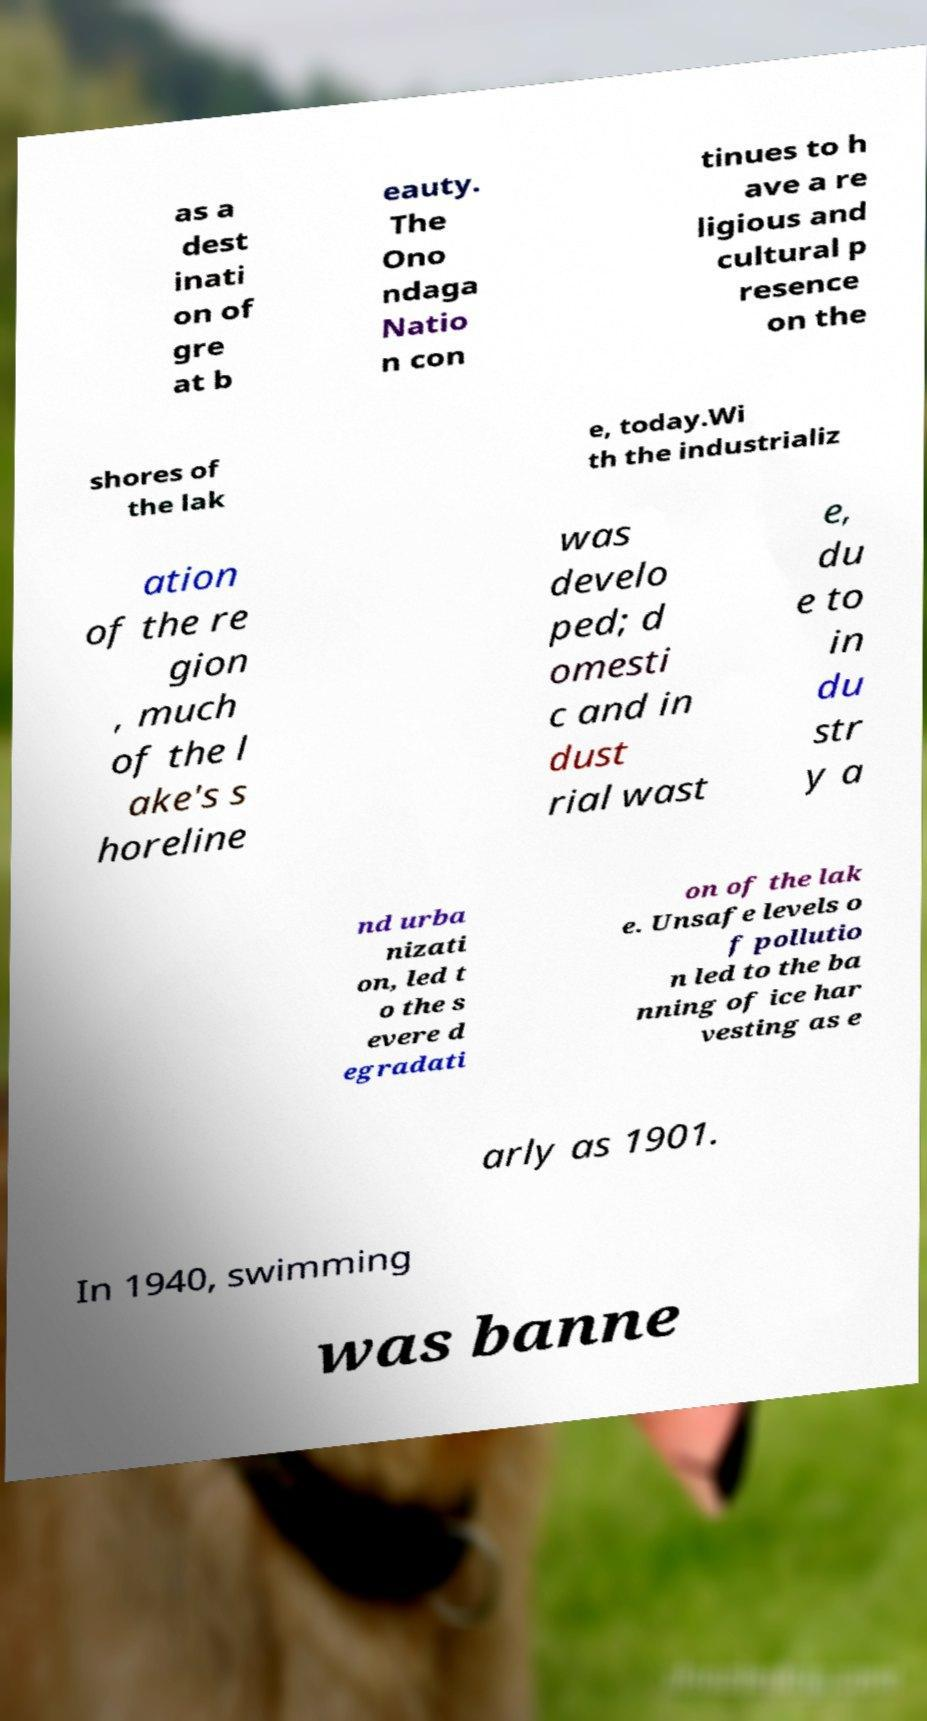Can you accurately transcribe the text from the provided image for me? as a dest inati on of gre at b eauty. The Ono ndaga Natio n con tinues to h ave a re ligious and cultural p resence on the shores of the lak e, today.Wi th the industrializ ation of the re gion , much of the l ake's s horeline was develo ped; d omesti c and in dust rial wast e, du e to in du str y a nd urba nizati on, led t o the s evere d egradati on of the lak e. Unsafe levels o f pollutio n led to the ba nning of ice har vesting as e arly as 1901. In 1940, swimming was banne 